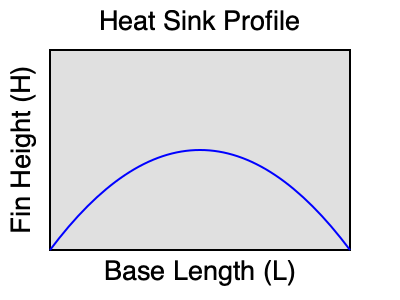A heat sink for a high-performance processor needs to be designed for optimal thermal management. The heat sink has a base length $L$ and fin height $H$. Given that the thermal resistance $R_{th}$ of the heat sink is inversely proportional to the square root of the product of $L$ and $H$, and directly proportional to a constant $k$, express $R_{th}$ in terms of $L$, $H$, and $k$. If the design constraint requires minimizing the volume $V = L \cdot H \cdot W$ (where $W$ is the width) while maintaining a constant $R_{th}$, what is the optimal ratio of $H$ to $L$? 1. Express $R_{th}$ in terms of $L$, $H$, and $k$:
   $R_{th} = \frac{k}{\sqrt{L \cdot H}}$

2. The volume of the heat sink is given by:
   $V = L \cdot H \cdot W$

3. To minimize volume while maintaining constant $R_{th}$, we need to find the optimal ratio of $H$ to $L$. Let's call this ratio $r = \frac{H}{L}$.

4. Substitute $H = r \cdot L$ into the $R_{th}$ equation:
   $R_{th} = \frac{k}{\sqrt{L \cdot (r \cdot L)}} = \frac{k}{\sqrt{r \cdot L^2}} = \frac{k}{L \sqrt{r}}$

5. For a constant $R_{th}$, $L \sqrt{r}$ must be constant. Let's call this constant $C$:
   $L \sqrt{r} = C$

6. Express $L$ in terms of $r$:
   $L = \frac{C}{\sqrt{r}}$

7. Express $H$ in terms of $r$:
   $H = r \cdot L = r \cdot \frac{C}{\sqrt{r}} = C \sqrt{r}$

8. The volume can now be expressed as:
   $V = L \cdot H \cdot W = \frac{C}{\sqrt{r}} \cdot C \sqrt{r} \cdot W = C^2 W$

9. We see that the volume is independent of $r$, meaning any ratio of $H$ to $L$ will result in the same volume for a given $R_{th}$.

10. However, to minimize material usage and weight, we should choose $H = L$, which means $r = 1$.

Therefore, the optimal ratio of $H$ to $L$ is 1:1.
Answer: 1:1 